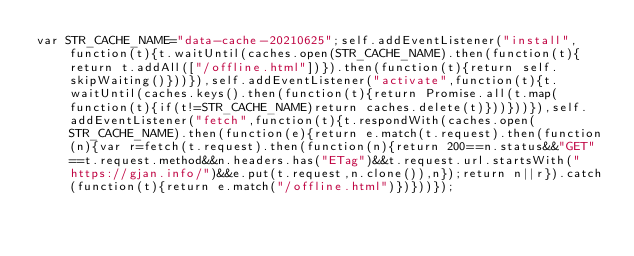Convert code to text. <code><loc_0><loc_0><loc_500><loc_500><_JavaScript_>var STR_CACHE_NAME="data-cache-20210625";self.addEventListener("install",function(t){t.waitUntil(caches.open(STR_CACHE_NAME).then(function(t){return t.addAll(["/offline.html"])}).then(function(t){return self.skipWaiting()}))}),self.addEventListener("activate",function(t){t.waitUntil(caches.keys().then(function(t){return Promise.all(t.map(function(t){if(t!=STR_CACHE_NAME)return caches.delete(t)}))}))}),self.addEventListener("fetch",function(t){t.respondWith(caches.open(STR_CACHE_NAME).then(function(e){return e.match(t.request).then(function(n){var r=fetch(t.request).then(function(n){return 200==n.status&&"GET"==t.request.method&&n.headers.has("ETag")&&t.request.url.startsWith("https://gjan.info/")&&e.put(t.request,n.clone()),n});return n||r}).catch(function(t){return e.match("/offline.html")})}))});
</code> 